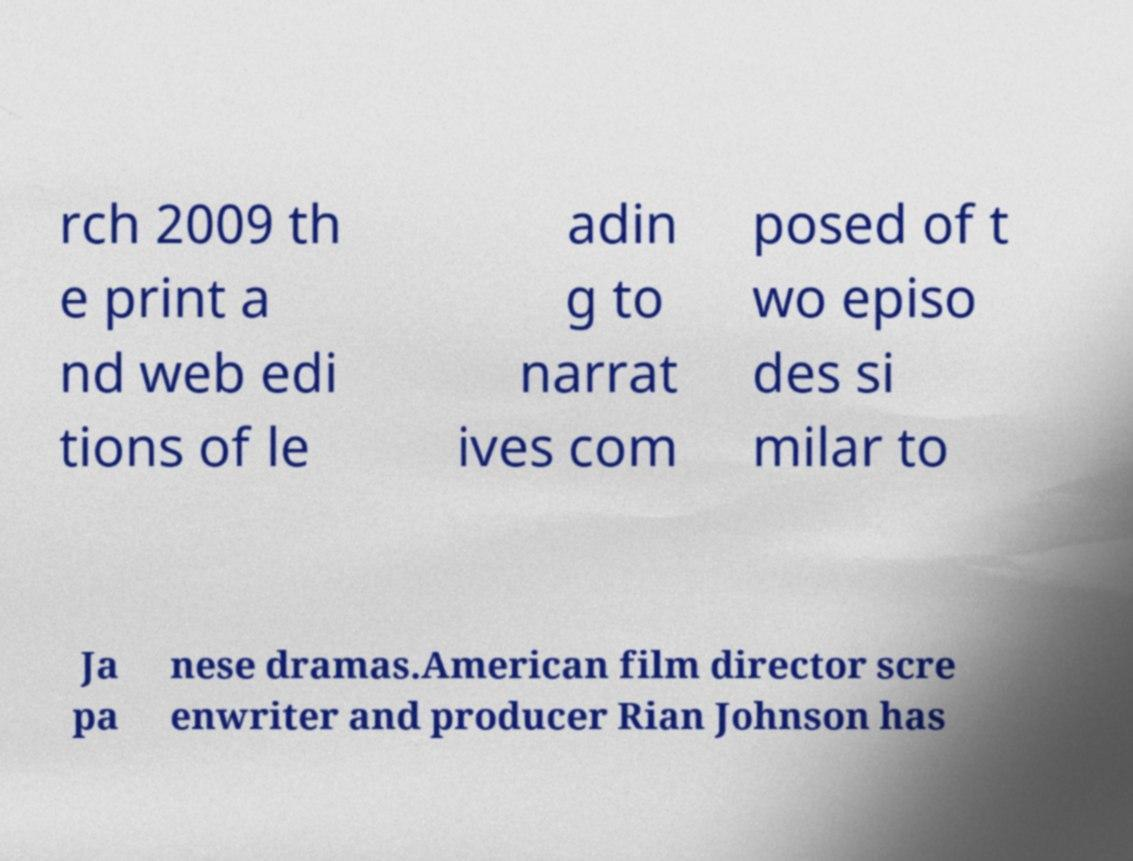Can you read and provide the text displayed in the image?This photo seems to have some interesting text. Can you extract and type it out for me? rch 2009 th e print a nd web edi tions of le adin g to narrat ives com posed of t wo episo des si milar to Ja pa nese dramas.American film director scre enwriter and producer Rian Johnson has 